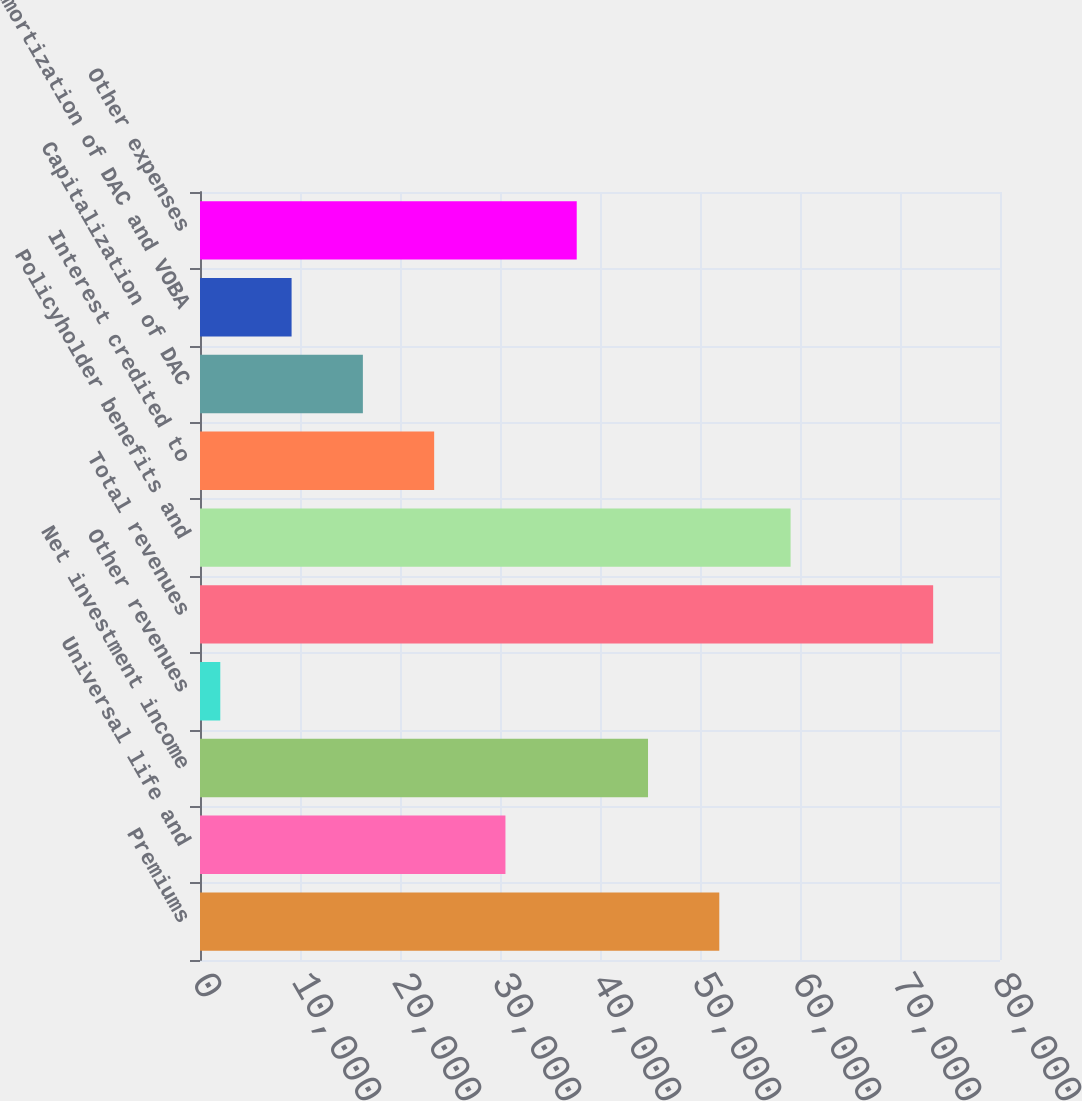<chart> <loc_0><loc_0><loc_500><loc_500><bar_chart><fcel>Premiums<fcel>Universal life and<fcel>Net investment income<fcel>Other revenues<fcel>Total revenues<fcel>Policyholder benefits and<fcel>Interest credited to<fcel>Capitalization of DAC<fcel>Amortization of DAC and VOBA<fcel>Other expenses<nl><fcel>51930.2<fcel>30544.4<fcel>44801.6<fcel>2030<fcel>73316<fcel>59058.8<fcel>23415.8<fcel>16287.2<fcel>9158.6<fcel>37673<nl></chart> 